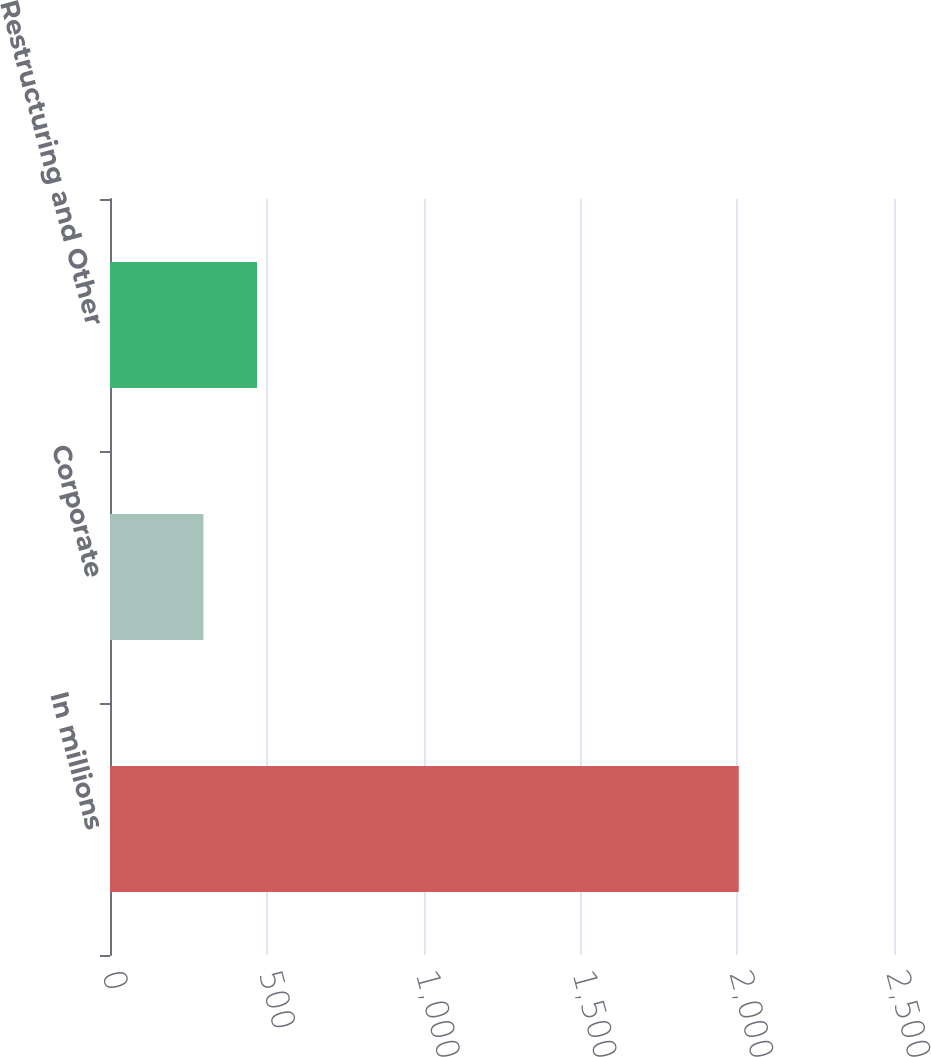<chart> <loc_0><loc_0><loc_500><loc_500><bar_chart><fcel>In millions<fcel>Corporate<fcel>Restructuring and Other<nl><fcel>2005<fcel>298<fcel>468.7<nl></chart> 